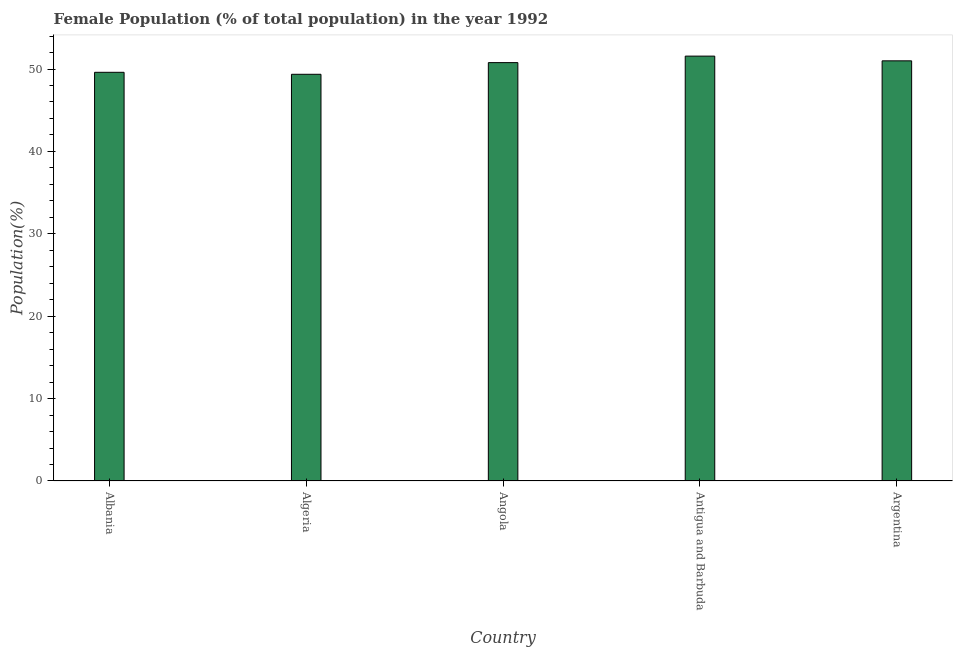Does the graph contain any zero values?
Ensure brevity in your answer.  No. What is the title of the graph?
Your answer should be very brief. Female Population (% of total population) in the year 1992. What is the label or title of the Y-axis?
Offer a very short reply. Population(%). What is the female population in Antigua and Barbuda?
Provide a succinct answer. 51.57. Across all countries, what is the maximum female population?
Keep it short and to the point. 51.57. Across all countries, what is the minimum female population?
Give a very brief answer. 49.36. In which country was the female population maximum?
Give a very brief answer. Antigua and Barbuda. In which country was the female population minimum?
Give a very brief answer. Algeria. What is the sum of the female population?
Offer a very short reply. 252.3. What is the difference between the female population in Angola and Antigua and Barbuda?
Keep it short and to the point. -0.79. What is the average female population per country?
Ensure brevity in your answer.  50.46. What is the median female population?
Your response must be concise. 50.78. In how many countries, is the female population greater than 24 %?
Provide a short and direct response. 5. Is the female population in Albania less than that in Antigua and Barbuda?
Make the answer very short. Yes. What is the difference between the highest and the second highest female population?
Provide a succinct answer. 0.57. Is the sum of the female population in Albania and Antigua and Barbuda greater than the maximum female population across all countries?
Your answer should be compact. Yes. What is the difference between the highest and the lowest female population?
Offer a very short reply. 2.21. How many countries are there in the graph?
Make the answer very short. 5. Are the values on the major ticks of Y-axis written in scientific E-notation?
Make the answer very short. No. What is the Population(%) in Albania?
Make the answer very short. 49.6. What is the Population(%) of Algeria?
Offer a very short reply. 49.36. What is the Population(%) in Angola?
Give a very brief answer. 50.78. What is the Population(%) in Antigua and Barbuda?
Your answer should be very brief. 51.57. What is the Population(%) of Argentina?
Offer a very short reply. 50.99. What is the difference between the Population(%) in Albania and Algeria?
Ensure brevity in your answer.  0.24. What is the difference between the Population(%) in Albania and Angola?
Make the answer very short. -1.17. What is the difference between the Population(%) in Albania and Antigua and Barbuda?
Make the answer very short. -1.96. What is the difference between the Population(%) in Albania and Argentina?
Keep it short and to the point. -1.39. What is the difference between the Population(%) in Algeria and Angola?
Make the answer very short. -1.42. What is the difference between the Population(%) in Algeria and Antigua and Barbuda?
Your answer should be compact. -2.21. What is the difference between the Population(%) in Algeria and Argentina?
Keep it short and to the point. -1.63. What is the difference between the Population(%) in Angola and Antigua and Barbuda?
Ensure brevity in your answer.  -0.79. What is the difference between the Population(%) in Angola and Argentina?
Your answer should be very brief. -0.22. What is the difference between the Population(%) in Antigua and Barbuda and Argentina?
Provide a short and direct response. 0.57. What is the ratio of the Population(%) in Albania to that in Algeria?
Make the answer very short. 1. What is the ratio of the Population(%) in Albania to that in Angola?
Your answer should be compact. 0.98. What is the ratio of the Population(%) in Albania to that in Argentina?
Ensure brevity in your answer.  0.97. What is the ratio of the Population(%) in Algeria to that in Angola?
Provide a succinct answer. 0.97. What is the ratio of the Population(%) in Algeria to that in Antigua and Barbuda?
Your answer should be compact. 0.96. What is the ratio of the Population(%) in Algeria to that in Argentina?
Your answer should be very brief. 0.97. What is the ratio of the Population(%) in Angola to that in Antigua and Barbuda?
Keep it short and to the point. 0.98. What is the ratio of the Population(%) in Antigua and Barbuda to that in Argentina?
Make the answer very short. 1.01. 